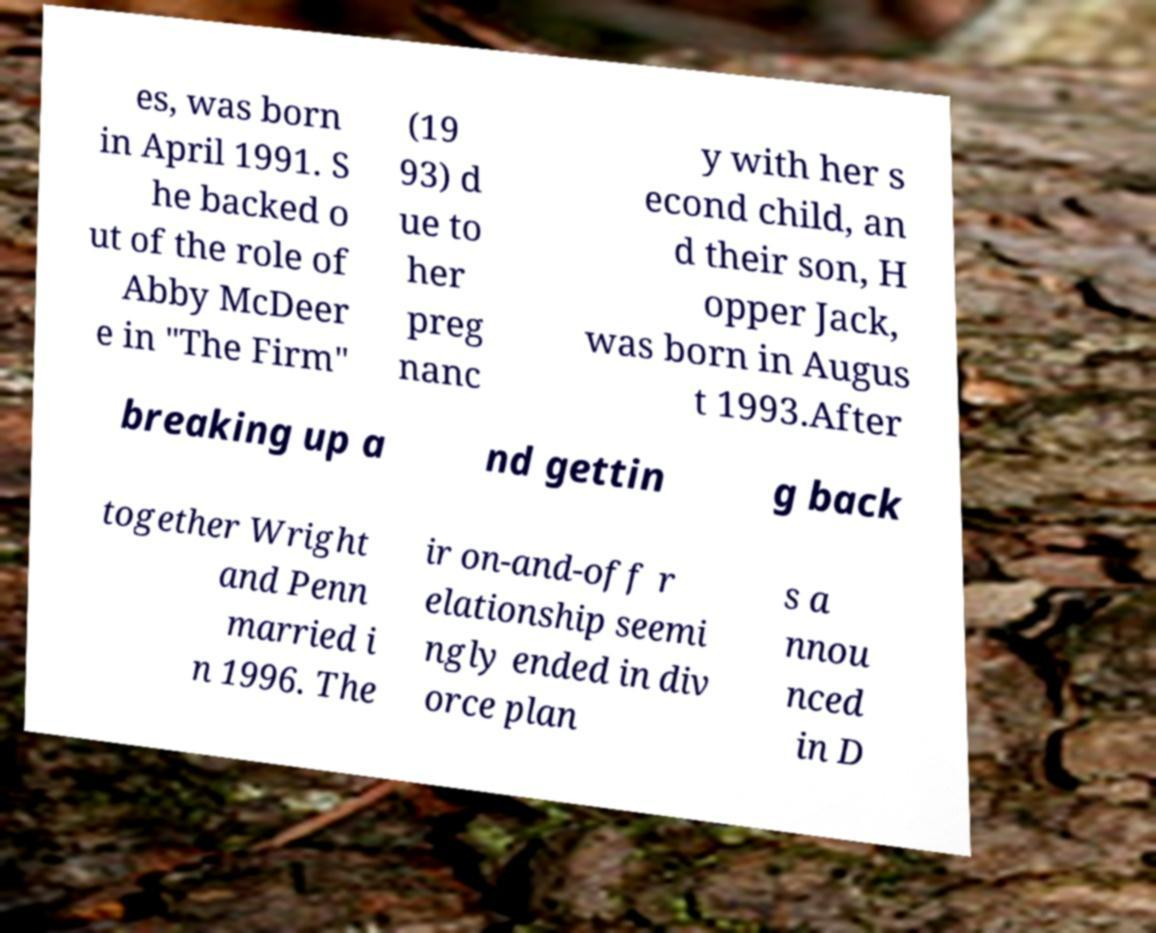Could you extract and type out the text from this image? es, was born in April 1991. S he backed o ut of the role of Abby McDeer e in "The Firm" (19 93) d ue to her preg nanc y with her s econd child, an d their son, H opper Jack, was born in Augus t 1993.After breaking up a nd gettin g back together Wright and Penn married i n 1996. The ir on-and-off r elationship seemi ngly ended in div orce plan s a nnou nced in D 